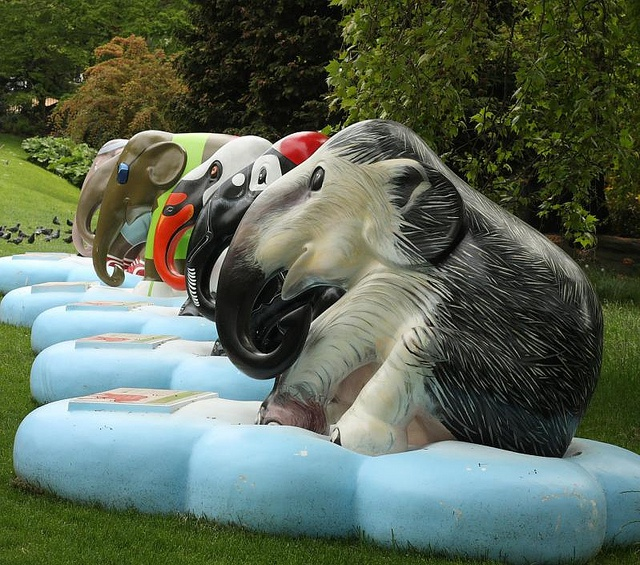Describe the objects in this image and their specific colors. I can see elephant in olive, black, gray, and darkgray tones, elephant in olive, darkgreen, black, and gray tones, elephant in olive, black, gray, lightgray, and darkgray tones, elephant in olive, gray, and darkgray tones, and bird in olive and darkgreen tones in this image. 